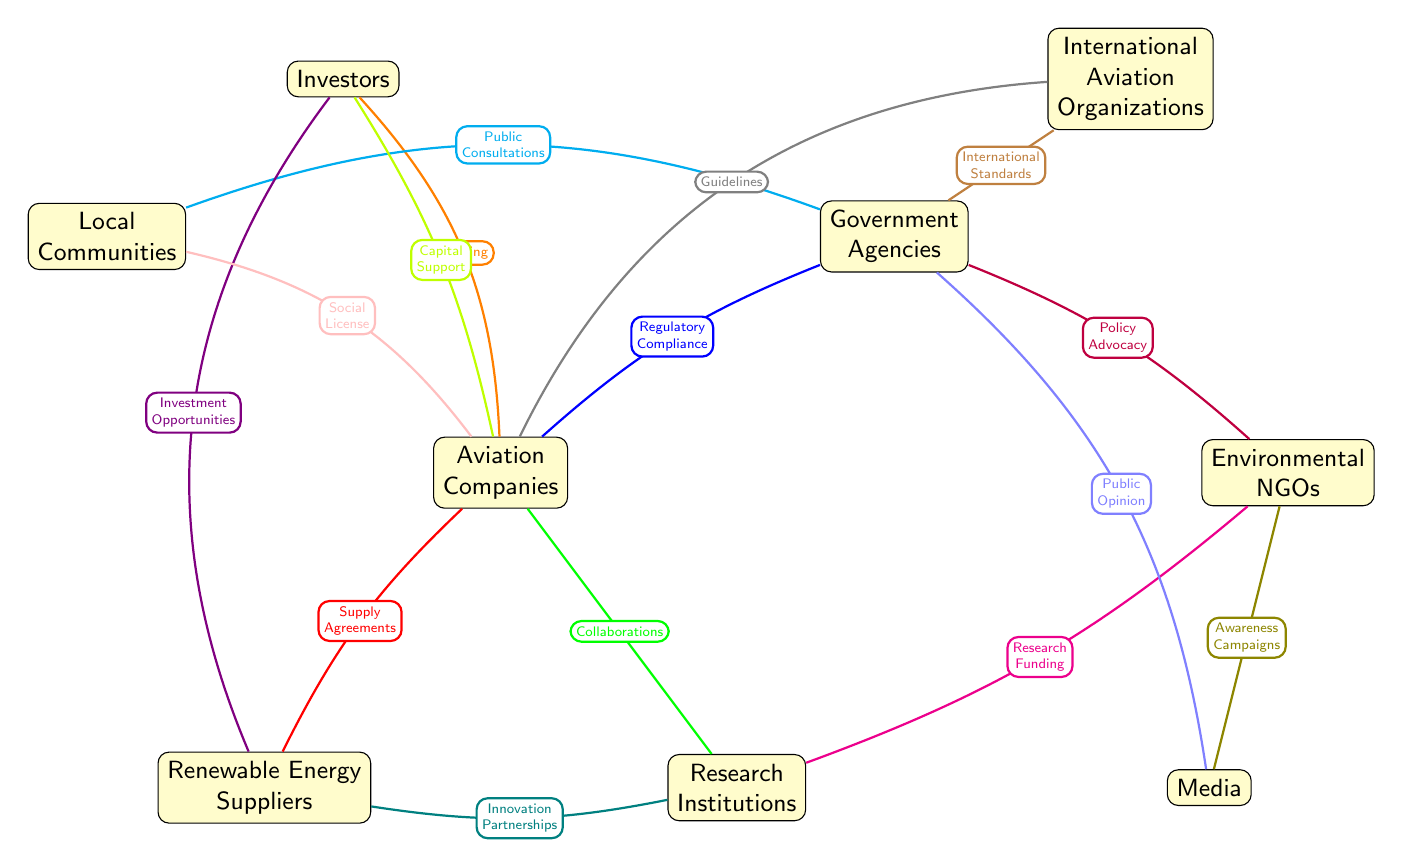What is the total number of nodes in the diagram? The diagram depicts various stakeholders involved in renewable energy policy-making in the aviation sector. Each distinct entity represented is a node, and counting them reveals a total of nine nodes.
Answer: 9 Which stakeholder is connected to both Government Agencies and Local Communities? By examining the edges originating from Government Agencies, we see that there is an edge labeled "Public Consultations" connecting it to Local Communities. This indicates that Government Agencies interact with Local Communities through this means.
Answer: Local Communities How do Aviation Companies collaborate with Research Institutions? The relationship between Aviation Companies and Research Institutions is portrayed by an edge labeled "Collaborations" which implies that there is a direct link showcasing their interaction. This collaboration is essential for developing renewable energy solutions within aviation.
Answer: Collaborations What type of influence does Media exert on Government Agencies? The influence of Media on Government Agencies is displayed through the edge labeled "Public Opinion". This implies that the Media plays a significant role in shaping the perceptions and decisions made by Government Agencies in relation to renewable energy policies.
Answer: Public Opinion Which two nodes are directly connected by the edge labeled "Innovation Partnerships"? The edge labeled "Innovation Partnerships" signifies a relationship between Renewable Energy Suppliers and Research Institutions, indicating a collaborative effort between these two stakeholders to foster innovation in renewable energy within the aviation sector.
Answer: Renewable Energy Suppliers, Research Institutions What is the primary action that Investors provide to Aviation Companies? The diagram shows an edge labeled "Funding" connecting Investors to Aviation Companies which suggests that the main contribution of Investors is financial support aimed at facilitating projects related to renewable energy in aviation.
Answer: Funding Which node has the least number of direct connections in the diagram? By analyzing the number of edges connected to each node, I find that Environmental NGOs only have two direct connections, making it the node with the least connections in the diagram, compared to others which have more extensive interactions.
Answer: Environmental NGOs What is the connection between International Aviation Organizations and Aviation Companies? The diagram indicates that International Aviation Organizations influence Aviation Companies through "Guidelines", suggesting these organizations provide rules or standards that Aviation Companies adhere to in their operations.
Answer: Guidelines In terms of the stakeholders, who primarily advocates for policies affecting renewable energy? Government Agencies are linked with Environmental NGOs through "Policy Advocacy", indicating that Government Agencies have an influential role in promoting policies that enhance renewable energy usage in aviation, supported by Environmental NGOs.
Answer: Government Agencies 